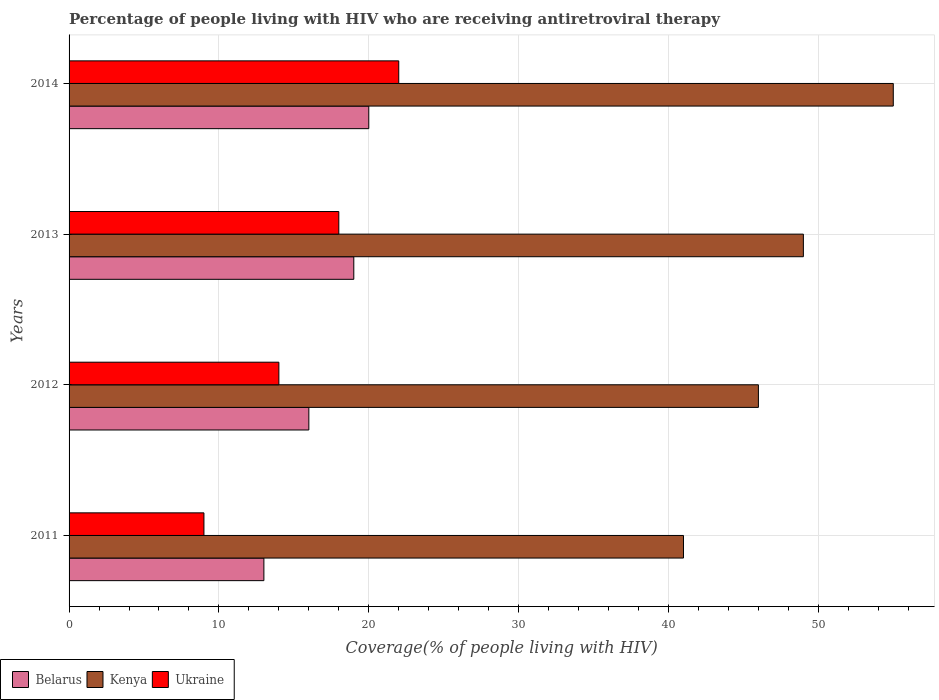How many groups of bars are there?
Make the answer very short. 4. How many bars are there on the 2nd tick from the top?
Your answer should be very brief. 3. How many bars are there on the 2nd tick from the bottom?
Provide a succinct answer. 3. In how many cases, is the number of bars for a given year not equal to the number of legend labels?
Provide a short and direct response. 0. What is the percentage of the HIV infected people who are receiving antiretroviral therapy in Ukraine in 2012?
Offer a terse response. 14. Across all years, what is the maximum percentage of the HIV infected people who are receiving antiretroviral therapy in Belarus?
Give a very brief answer. 20. Across all years, what is the minimum percentage of the HIV infected people who are receiving antiretroviral therapy in Ukraine?
Offer a terse response. 9. In which year was the percentage of the HIV infected people who are receiving antiretroviral therapy in Kenya maximum?
Your response must be concise. 2014. In which year was the percentage of the HIV infected people who are receiving antiretroviral therapy in Ukraine minimum?
Your answer should be very brief. 2011. What is the total percentage of the HIV infected people who are receiving antiretroviral therapy in Kenya in the graph?
Your answer should be compact. 191. What is the difference between the percentage of the HIV infected people who are receiving antiretroviral therapy in Belarus in 2012 and that in 2013?
Keep it short and to the point. -3. What is the difference between the percentage of the HIV infected people who are receiving antiretroviral therapy in Kenya in 2011 and the percentage of the HIV infected people who are receiving antiretroviral therapy in Ukraine in 2012?
Keep it short and to the point. 27. What is the average percentage of the HIV infected people who are receiving antiretroviral therapy in Ukraine per year?
Offer a very short reply. 15.75. In the year 2011, what is the difference between the percentage of the HIV infected people who are receiving antiretroviral therapy in Kenya and percentage of the HIV infected people who are receiving antiretroviral therapy in Belarus?
Your answer should be very brief. 28. What is the ratio of the percentage of the HIV infected people who are receiving antiretroviral therapy in Belarus in 2011 to that in 2013?
Your response must be concise. 0.68. Is the percentage of the HIV infected people who are receiving antiretroviral therapy in Kenya in 2011 less than that in 2012?
Give a very brief answer. Yes. What is the difference between the highest and the second highest percentage of the HIV infected people who are receiving antiretroviral therapy in Belarus?
Keep it short and to the point. 1. What is the difference between the highest and the lowest percentage of the HIV infected people who are receiving antiretroviral therapy in Ukraine?
Offer a terse response. 13. What does the 1st bar from the top in 2013 represents?
Your answer should be very brief. Ukraine. What does the 1st bar from the bottom in 2013 represents?
Provide a succinct answer. Belarus. Is it the case that in every year, the sum of the percentage of the HIV infected people who are receiving antiretroviral therapy in Belarus and percentage of the HIV infected people who are receiving antiretroviral therapy in Ukraine is greater than the percentage of the HIV infected people who are receiving antiretroviral therapy in Kenya?
Make the answer very short. No. How many years are there in the graph?
Your response must be concise. 4. What is the difference between two consecutive major ticks on the X-axis?
Give a very brief answer. 10. Are the values on the major ticks of X-axis written in scientific E-notation?
Offer a terse response. No. Where does the legend appear in the graph?
Your answer should be very brief. Bottom left. What is the title of the graph?
Offer a very short reply. Percentage of people living with HIV who are receiving antiretroviral therapy. What is the label or title of the X-axis?
Offer a terse response. Coverage(% of people living with HIV). What is the Coverage(% of people living with HIV) of Belarus in 2011?
Keep it short and to the point. 13. What is the Coverage(% of people living with HIV) of Belarus in 2012?
Provide a short and direct response. 16. What is the Coverage(% of people living with HIV) of Kenya in 2012?
Make the answer very short. 46. What is the Coverage(% of people living with HIV) of Kenya in 2013?
Offer a very short reply. 49. What is the Coverage(% of people living with HIV) of Kenya in 2014?
Make the answer very short. 55. What is the Coverage(% of people living with HIV) in Ukraine in 2014?
Provide a short and direct response. 22. Across all years, what is the maximum Coverage(% of people living with HIV) of Belarus?
Offer a very short reply. 20. Across all years, what is the maximum Coverage(% of people living with HIV) of Kenya?
Ensure brevity in your answer.  55. Across all years, what is the minimum Coverage(% of people living with HIV) of Belarus?
Provide a short and direct response. 13. Across all years, what is the minimum Coverage(% of people living with HIV) in Kenya?
Offer a terse response. 41. Across all years, what is the minimum Coverage(% of people living with HIV) in Ukraine?
Offer a very short reply. 9. What is the total Coverage(% of people living with HIV) in Kenya in the graph?
Keep it short and to the point. 191. What is the difference between the Coverage(% of people living with HIV) of Belarus in 2011 and that in 2012?
Provide a succinct answer. -3. What is the difference between the Coverage(% of people living with HIV) of Kenya in 2011 and that in 2012?
Offer a terse response. -5. What is the difference between the Coverage(% of people living with HIV) in Belarus in 2011 and that in 2013?
Offer a terse response. -6. What is the difference between the Coverage(% of people living with HIV) in Kenya in 2011 and that in 2013?
Offer a very short reply. -8. What is the difference between the Coverage(% of people living with HIV) of Belarus in 2011 and that in 2014?
Offer a very short reply. -7. What is the difference between the Coverage(% of people living with HIV) of Ukraine in 2011 and that in 2014?
Provide a short and direct response. -13. What is the difference between the Coverage(% of people living with HIV) in Kenya in 2012 and that in 2013?
Your response must be concise. -3. What is the difference between the Coverage(% of people living with HIV) of Ukraine in 2012 and that in 2013?
Your answer should be compact. -4. What is the difference between the Coverage(% of people living with HIV) in Belarus in 2012 and that in 2014?
Offer a terse response. -4. What is the difference between the Coverage(% of people living with HIV) of Ukraine in 2012 and that in 2014?
Offer a very short reply. -8. What is the difference between the Coverage(% of people living with HIV) of Belarus in 2013 and that in 2014?
Give a very brief answer. -1. What is the difference between the Coverage(% of people living with HIV) of Ukraine in 2013 and that in 2014?
Offer a very short reply. -4. What is the difference between the Coverage(% of people living with HIV) of Belarus in 2011 and the Coverage(% of people living with HIV) of Kenya in 2012?
Your response must be concise. -33. What is the difference between the Coverage(% of people living with HIV) of Belarus in 2011 and the Coverage(% of people living with HIV) of Ukraine in 2012?
Your response must be concise. -1. What is the difference between the Coverage(% of people living with HIV) in Belarus in 2011 and the Coverage(% of people living with HIV) in Kenya in 2013?
Your answer should be compact. -36. What is the difference between the Coverage(% of people living with HIV) of Belarus in 2011 and the Coverage(% of people living with HIV) of Ukraine in 2013?
Ensure brevity in your answer.  -5. What is the difference between the Coverage(% of people living with HIV) in Kenya in 2011 and the Coverage(% of people living with HIV) in Ukraine in 2013?
Your response must be concise. 23. What is the difference between the Coverage(% of people living with HIV) in Belarus in 2011 and the Coverage(% of people living with HIV) in Kenya in 2014?
Ensure brevity in your answer.  -42. What is the difference between the Coverage(% of people living with HIV) of Belarus in 2011 and the Coverage(% of people living with HIV) of Ukraine in 2014?
Keep it short and to the point. -9. What is the difference between the Coverage(% of people living with HIV) of Belarus in 2012 and the Coverage(% of people living with HIV) of Kenya in 2013?
Offer a terse response. -33. What is the difference between the Coverage(% of people living with HIV) in Belarus in 2012 and the Coverage(% of people living with HIV) in Kenya in 2014?
Make the answer very short. -39. What is the difference between the Coverage(% of people living with HIV) in Belarus in 2012 and the Coverage(% of people living with HIV) in Ukraine in 2014?
Keep it short and to the point. -6. What is the difference between the Coverage(% of people living with HIV) in Kenya in 2012 and the Coverage(% of people living with HIV) in Ukraine in 2014?
Offer a terse response. 24. What is the difference between the Coverage(% of people living with HIV) in Belarus in 2013 and the Coverage(% of people living with HIV) in Kenya in 2014?
Your response must be concise. -36. What is the average Coverage(% of people living with HIV) of Belarus per year?
Your response must be concise. 17. What is the average Coverage(% of people living with HIV) in Kenya per year?
Offer a terse response. 47.75. What is the average Coverage(% of people living with HIV) in Ukraine per year?
Give a very brief answer. 15.75. In the year 2011, what is the difference between the Coverage(% of people living with HIV) in Belarus and Coverage(% of people living with HIV) in Kenya?
Your answer should be compact. -28. In the year 2011, what is the difference between the Coverage(% of people living with HIV) of Belarus and Coverage(% of people living with HIV) of Ukraine?
Your answer should be very brief. 4. In the year 2012, what is the difference between the Coverage(% of people living with HIV) of Belarus and Coverage(% of people living with HIV) of Ukraine?
Provide a short and direct response. 2. In the year 2012, what is the difference between the Coverage(% of people living with HIV) of Kenya and Coverage(% of people living with HIV) of Ukraine?
Offer a very short reply. 32. In the year 2013, what is the difference between the Coverage(% of people living with HIV) of Kenya and Coverage(% of people living with HIV) of Ukraine?
Keep it short and to the point. 31. In the year 2014, what is the difference between the Coverage(% of people living with HIV) in Belarus and Coverage(% of people living with HIV) in Kenya?
Your answer should be very brief. -35. In the year 2014, what is the difference between the Coverage(% of people living with HIV) in Belarus and Coverage(% of people living with HIV) in Ukraine?
Provide a short and direct response. -2. In the year 2014, what is the difference between the Coverage(% of people living with HIV) of Kenya and Coverage(% of people living with HIV) of Ukraine?
Make the answer very short. 33. What is the ratio of the Coverage(% of people living with HIV) of Belarus in 2011 to that in 2012?
Your answer should be very brief. 0.81. What is the ratio of the Coverage(% of people living with HIV) of Kenya in 2011 to that in 2012?
Make the answer very short. 0.89. What is the ratio of the Coverage(% of people living with HIV) in Ukraine in 2011 to that in 2012?
Your response must be concise. 0.64. What is the ratio of the Coverage(% of people living with HIV) in Belarus in 2011 to that in 2013?
Your answer should be compact. 0.68. What is the ratio of the Coverage(% of people living with HIV) in Kenya in 2011 to that in 2013?
Offer a very short reply. 0.84. What is the ratio of the Coverage(% of people living with HIV) of Belarus in 2011 to that in 2014?
Keep it short and to the point. 0.65. What is the ratio of the Coverage(% of people living with HIV) of Kenya in 2011 to that in 2014?
Provide a succinct answer. 0.75. What is the ratio of the Coverage(% of people living with HIV) in Ukraine in 2011 to that in 2014?
Your response must be concise. 0.41. What is the ratio of the Coverage(% of people living with HIV) of Belarus in 2012 to that in 2013?
Ensure brevity in your answer.  0.84. What is the ratio of the Coverage(% of people living with HIV) in Kenya in 2012 to that in 2013?
Offer a very short reply. 0.94. What is the ratio of the Coverage(% of people living with HIV) in Kenya in 2012 to that in 2014?
Ensure brevity in your answer.  0.84. What is the ratio of the Coverage(% of people living with HIV) in Ukraine in 2012 to that in 2014?
Make the answer very short. 0.64. What is the ratio of the Coverage(% of people living with HIV) in Kenya in 2013 to that in 2014?
Offer a terse response. 0.89. What is the ratio of the Coverage(% of people living with HIV) of Ukraine in 2013 to that in 2014?
Provide a succinct answer. 0.82. What is the difference between the highest and the second highest Coverage(% of people living with HIV) of Belarus?
Your answer should be very brief. 1. What is the difference between the highest and the lowest Coverage(% of people living with HIV) in Belarus?
Make the answer very short. 7. What is the difference between the highest and the lowest Coverage(% of people living with HIV) in Kenya?
Give a very brief answer. 14. What is the difference between the highest and the lowest Coverage(% of people living with HIV) of Ukraine?
Your answer should be very brief. 13. 